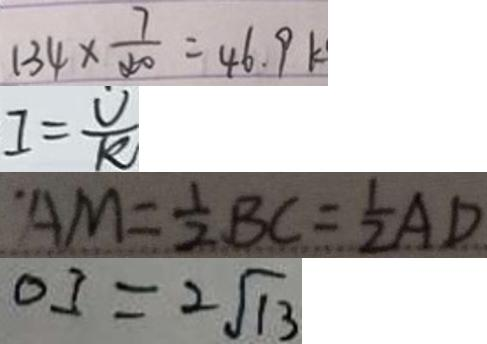Convert formula to latex. <formula><loc_0><loc_0><loc_500><loc_500>1 3 4 \times \frac { 7 } { 4 0 } = 4 6 . 9 k 
 I = \frac { U } { R } 
 A M = \frac { 1 } { 2 } B C = \frac { 1 } { 2 } A D 
 O I = 2 \sqrt { 1 3 }</formula> 